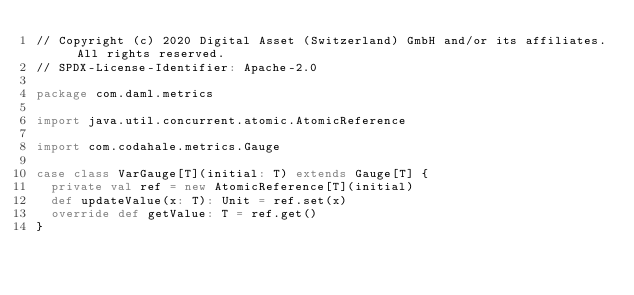Convert code to text. <code><loc_0><loc_0><loc_500><loc_500><_Scala_>// Copyright (c) 2020 Digital Asset (Switzerland) GmbH and/or its affiliates. All rights reserved.
// SPDX-License-Identifier: Apache-2.0

package com.daml.metrics

import java.util.concurrent.atomic.AtomicReference

import com.codahale.metrics.Gauge

case class VarGauge[T](initial: T) extends Gauge[T] {
  private val ref = new AtomicReference[T](initial)
  def updateValue(x: T): Unit = ref.set(x)
  override def getValue: T = ref.get()
}
</code> 